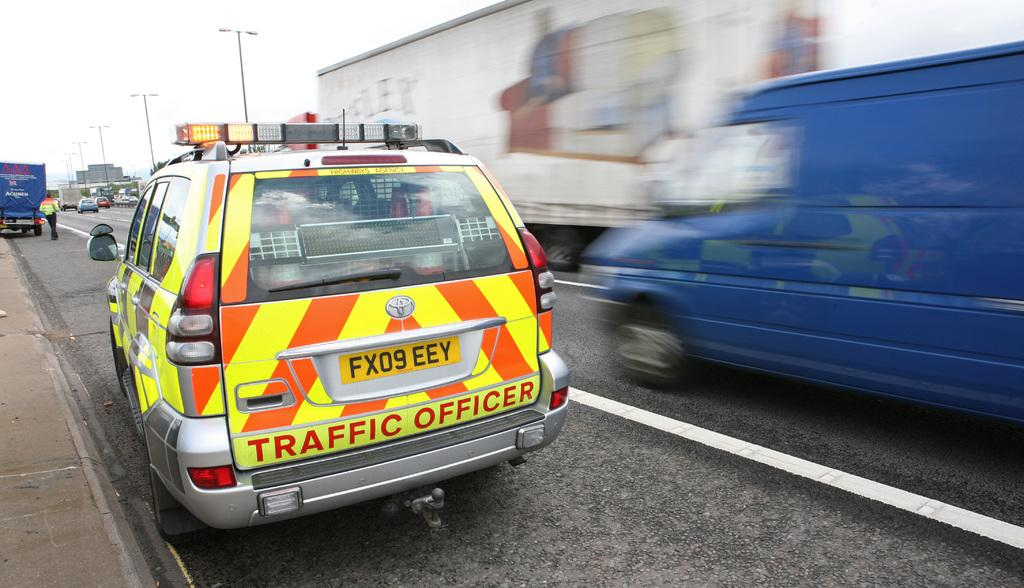<image>
Offer a succinct explanation of the picture presented. An orange and green Traffic officer van is parked near a side walk. 